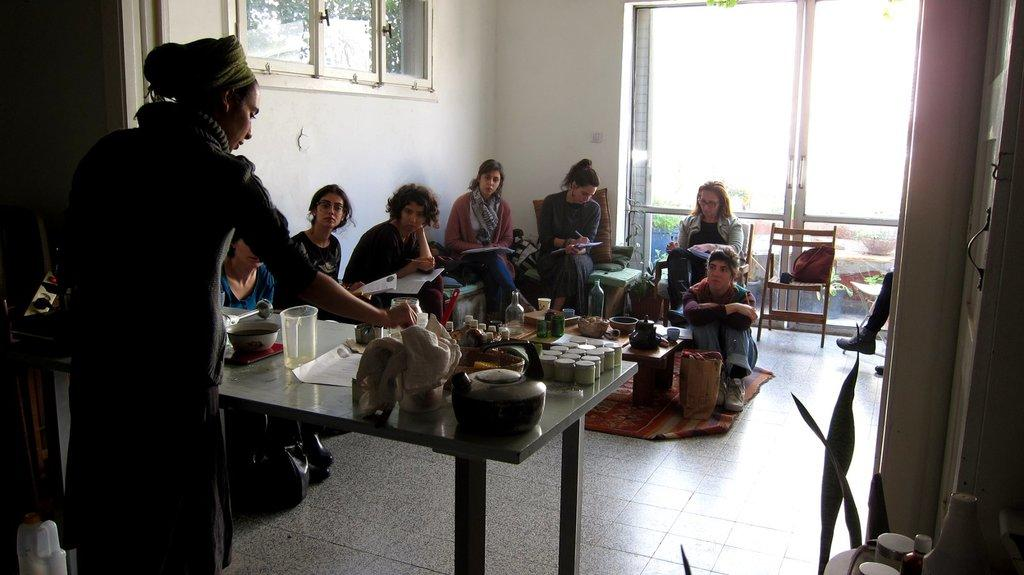What is the woman in the image doing? The woman is cooking in the image. What are the people sitting on chairs doing? The people are writing in books. Can you describe the type of window in the image? There is a glass window in the image. What type of thrill can be seen on the top of the woman's head in the image? There is no thrill or any object on the top of the woman's head in the image. How does the earthquake affect the people sitting on chairs in the image? There is no earthquake depicted in the image; the people are sitting calmly and writing in books. 